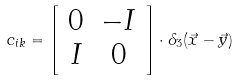<formula> <loc_0><loc_0><loc_500><loc_500>c _ { i k } = \left [ \begin{array} { c c } 0 & - I \\ I & 0 \end{array} \right ] \cdot \delta _ { 3 } ( \vec { x } - \vec { y } )</formula> 